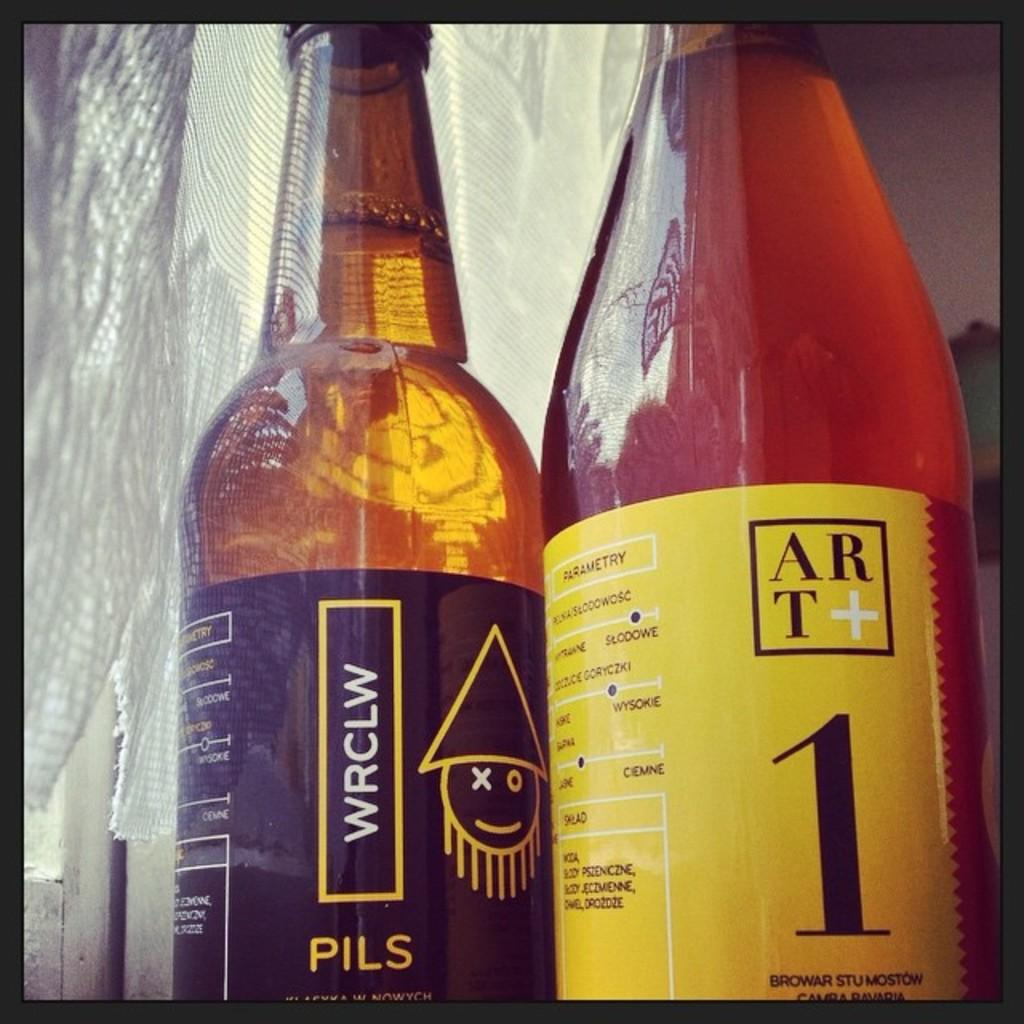Provide a one-sentence caption for the provided image. A close up of two bottles of PILS lager, one has a black label the other, yellow. 